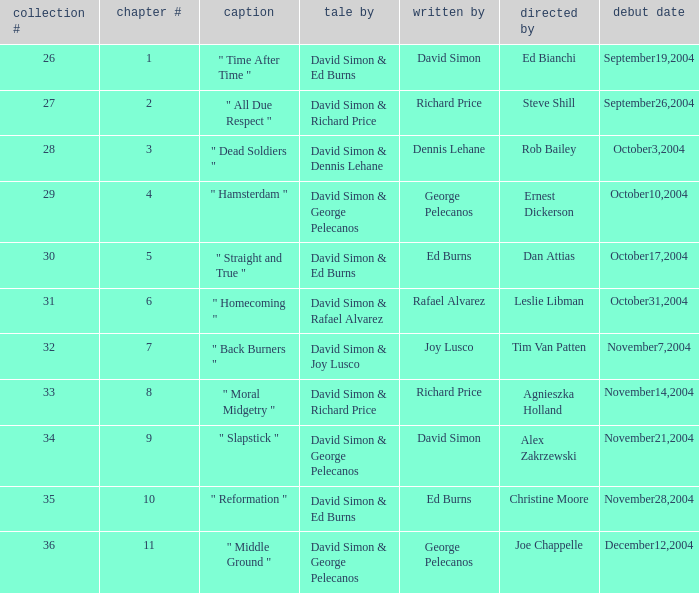What is the total number of values for "Teleplay by" category for series # 35? 1.0. 